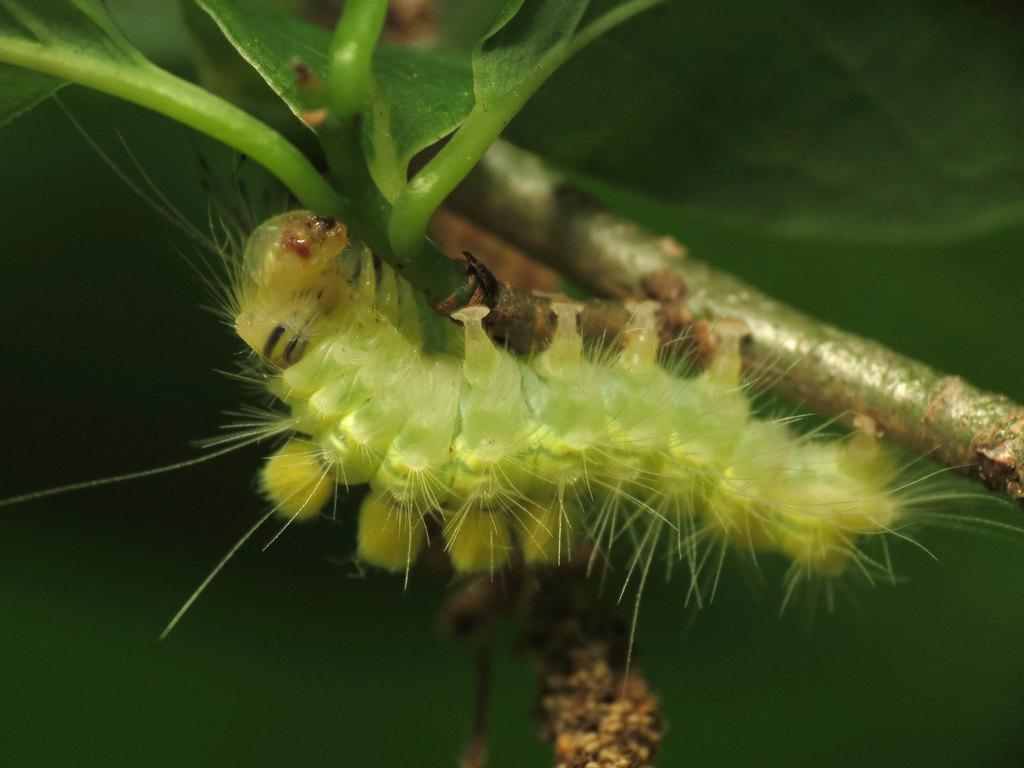What is located on the stem in the foreground of the image? There is an insect on the stem in the foreground of the image. What can be seen at the top of the image? There are leaves at the top of the image. What color dominates the background of the image? The background of the image is green. What type of apples are being picked by the dad in the image? There are no apples or dad present in the image; it features an insect on a stem with leaves and a green background. 